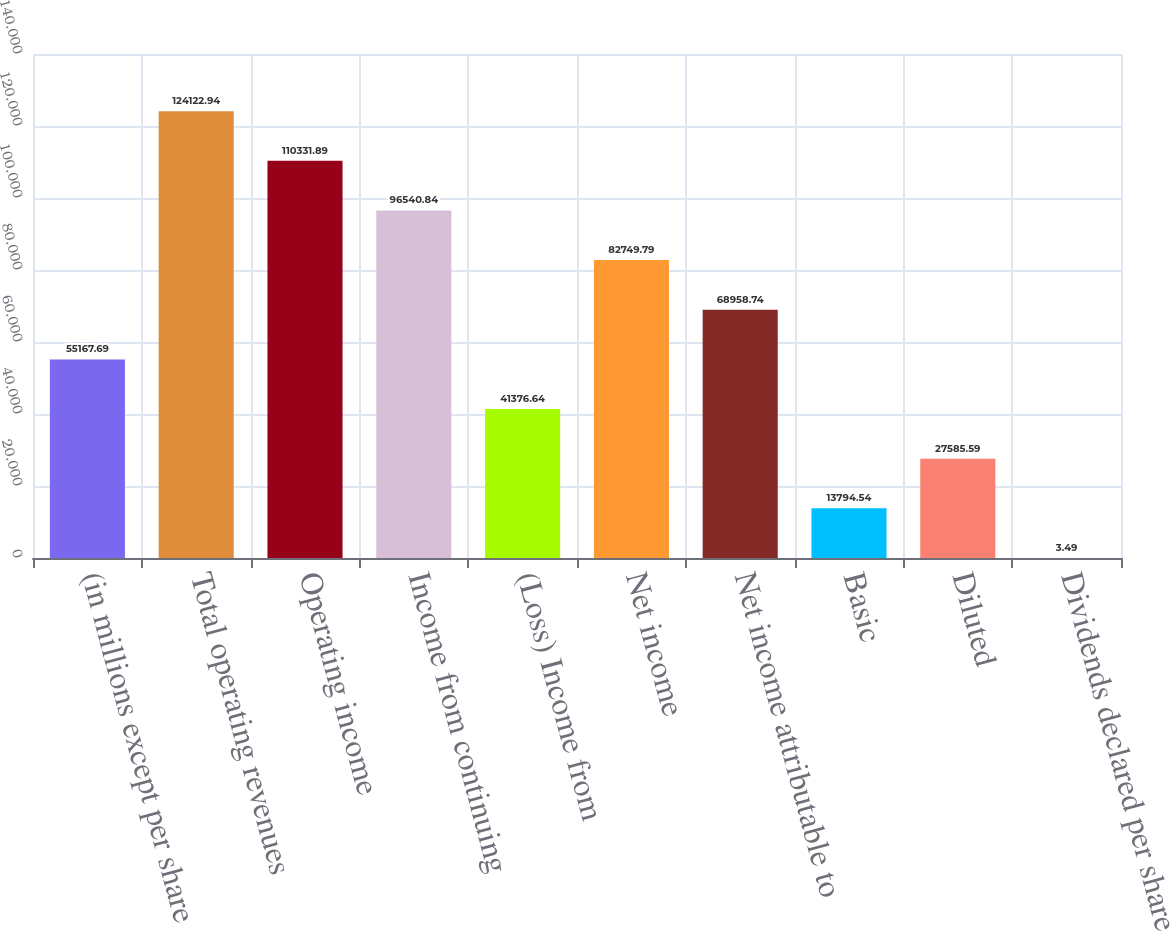Convert chart to OTSL. <chart><loc_0><loc_0><loc_500><loc_500><bar_chart><fcel>(in millions except per share<fcel>Total operating revenues<fcel>Operating income<fcel>Income from continuing<fcel>(Loss) Income from<fcel>Net income<fcel>Net income attributable to<fcel>Basic<fcel>Diluted<fcel>Dividends declared per share<nl><fcel>55167.7<fcel>124123<fcel>110332<fcel>96540.8<fcel>41376.6<fcel>82749.8<fcel>68958.7<fcel>13794.5<fcel>27585.6<fcel>3.49<nl></chart> 